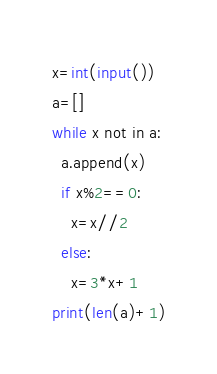<code> <loc_0><loc_0><loc_500><loc_500><_Python_>x=int(input())
a=[]
while x not in a:
  a.append(x)
  if x%2==0:
    x=x//2
  else:
    x=3*x+1
print(len(a)+1)</code> 